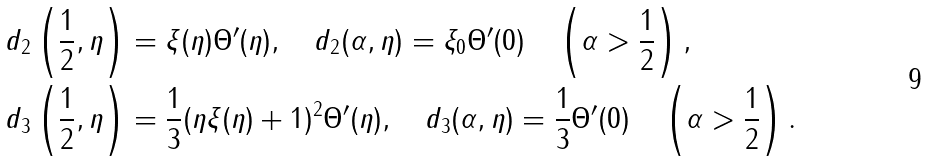<formula> <loc_0><loc_0><loc_500><loc_500>& d _ { 2 } \left ( \frac { 1 } { 2 } , \eta \right ) = \xi ( \eta ) \Theta ^ { \prime } ( \eta ) , \quad d _ { 2 } ( \alpha , \eta ) = \xi _ { 0 } \Theta ^ { \prime } ( 0 ) \quad \left ( \alpha > \frac { 1 } { 2 } \right ) , \\ & d _ { 3 } \left ( \frac { 1 } { 2 } , \eta \right ) = \frac { 1 } { 3 } ( \eta \xi ( \eta ) + 1 ) ^ { 2 } \Theta ^ { \prime } ( \eta ) , \quad d _ { 3 } ( \alpha , \eta ) = \frac { 1 } { 3 } \Theta ^ { \prime } ( 0 ) \quad \left ( \alpha > \frac { 1 } { 2 } \right ) .</formula> 